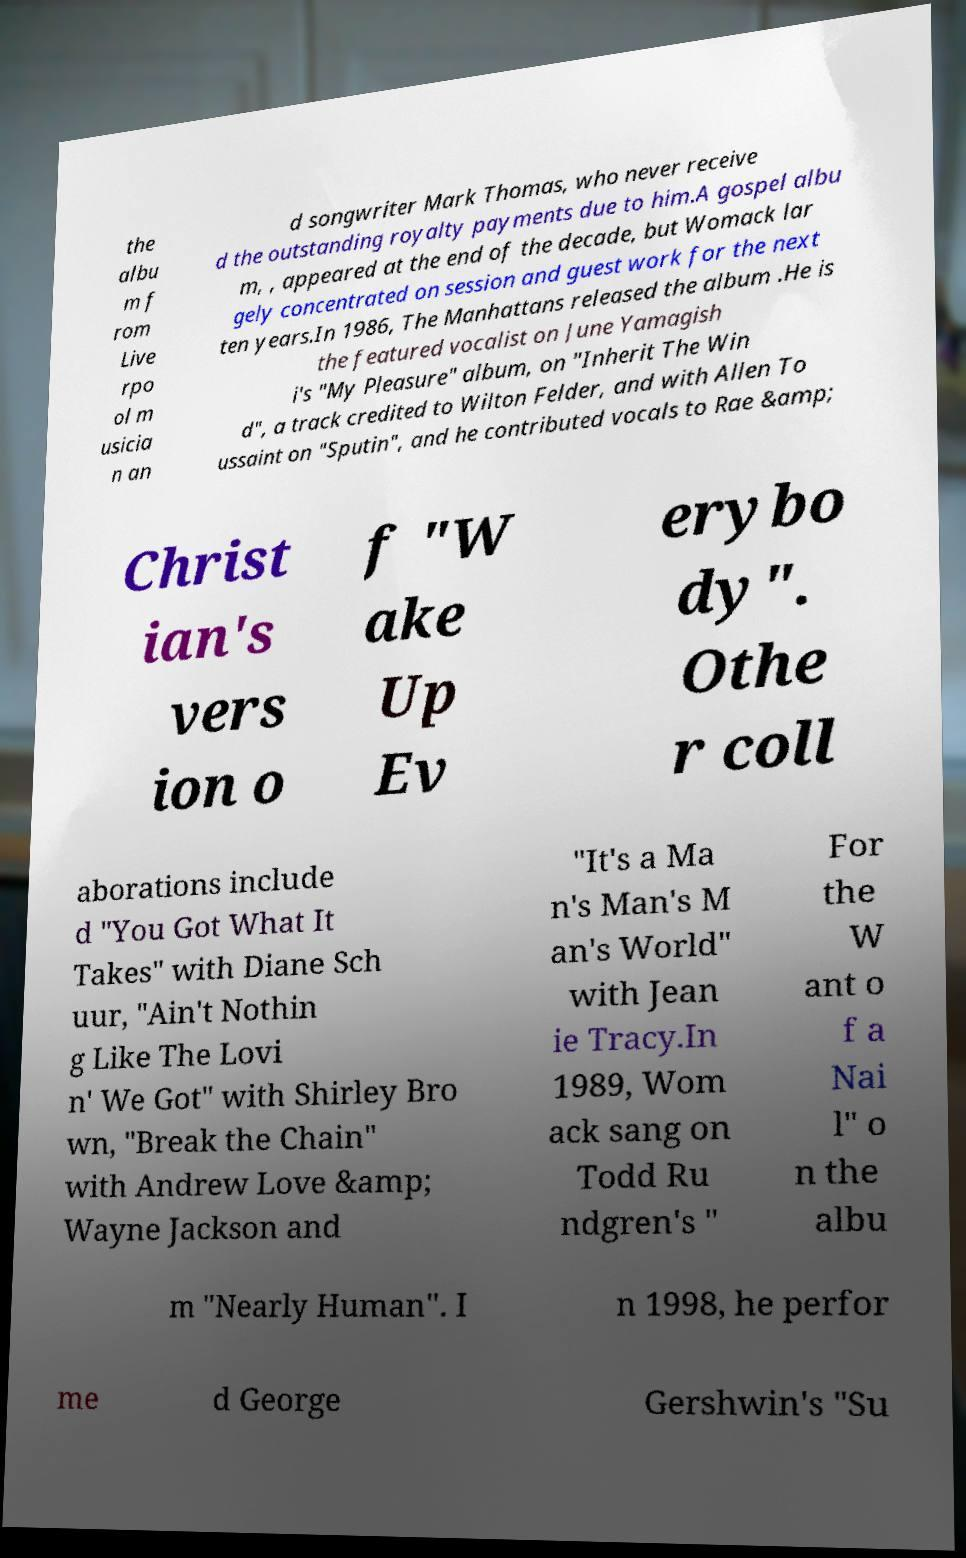Could you extract and type out the text from this image? the albu m f rom Live rpo ol m usicia n an d songwriter Mark Thomas, who never receive d the outstanding royalty payments due to him.A gospel albu m, , appeared at the end of the decade, but Womack lar gely concentrated on session and guest work for the next ten years.In 1986, The Manhattans released the album .He is the featured vocalist on June Yamagish i's "My Pleasure" album, on "Inherit The Win d", a track credited to Wilton Felder, and with Allen To ussaint on "Sputin", and he contributed vocals to Rae &amp; Christ ian's vers ion o f "W ake Up Ev erybo dy". Othe r coll aborations include d "You Got What It Takes" with Diane Sch uur, "Ain't Nothin g Like The Lovi n' We Got" with Shirley Bro wn, "Break the Chain" with Andrew Love &amp; Wayne Jackson and "It's a Ma n's Man's M an's World" with Jean ie Tracy.In 1989, Wom ack sang on Todd Ru ndgren's " For the W ant o f a Nai l" o n the albu m "Nearly Human". I n 1998, he perfor me d George Gershwin's "Su 